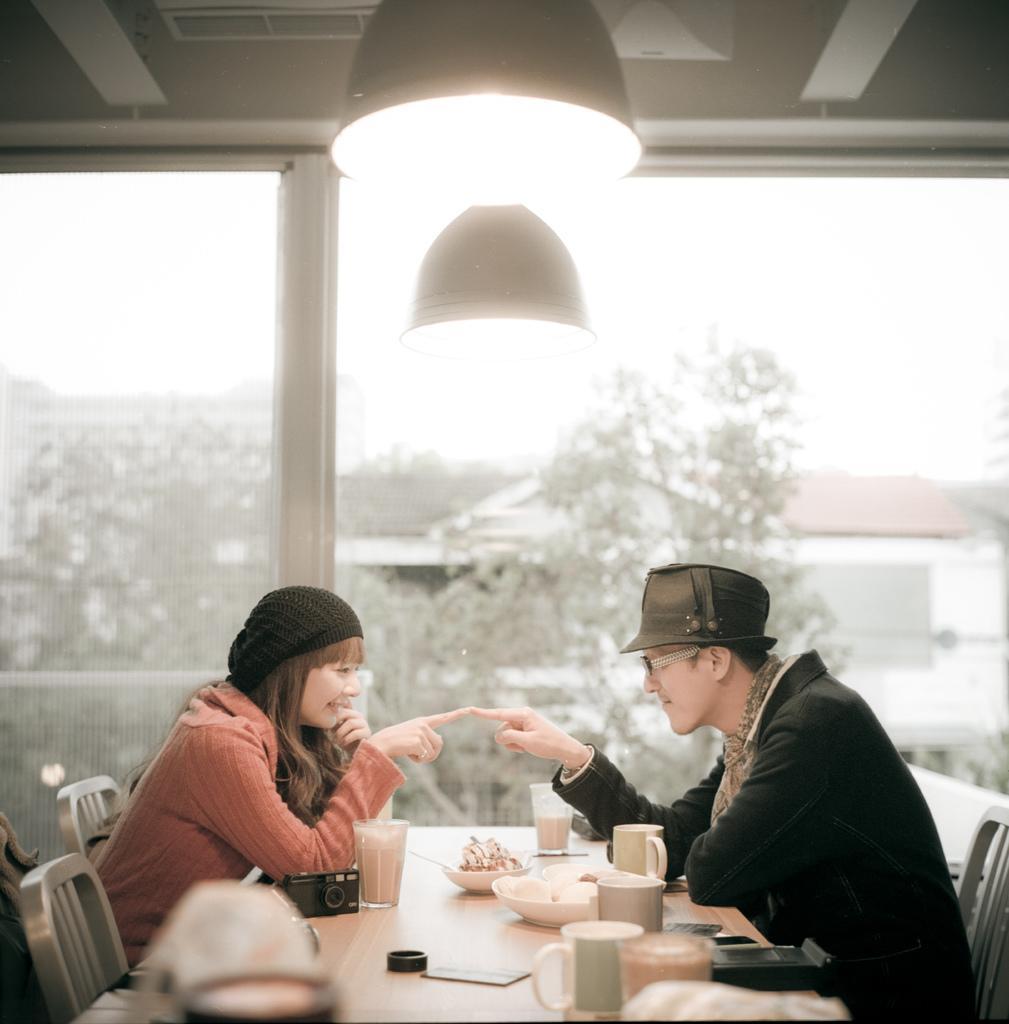Can you describe this image briefly? In this image on the right side there is one man who is sitting on a chair on the left side there is one woman who is sitting on a chair and smiling, in front of them there is one table on the table there is a plate, cups, and glasses are there on the table. On the background there are some trees and houses. On the top there is ceiling and light 